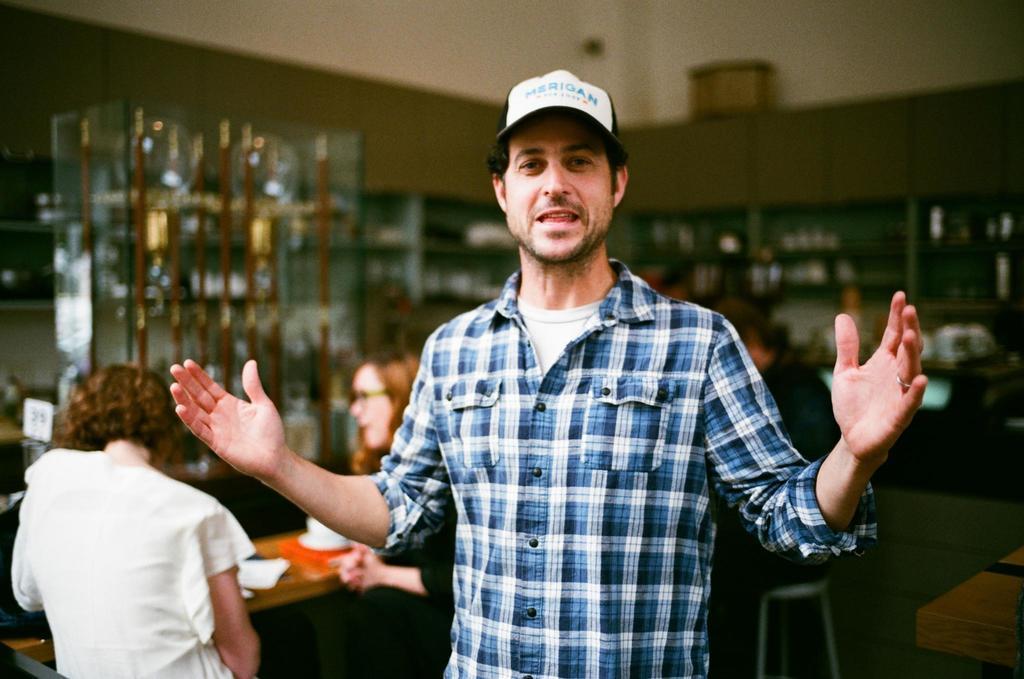How would you summarize this image in a sentence or two? In this image we can see a person wearing a cap. Behind the person we can see few people sitting and there are few objects on the table. In the background, we can see few objects on the racks. The background of the image is blurred. 